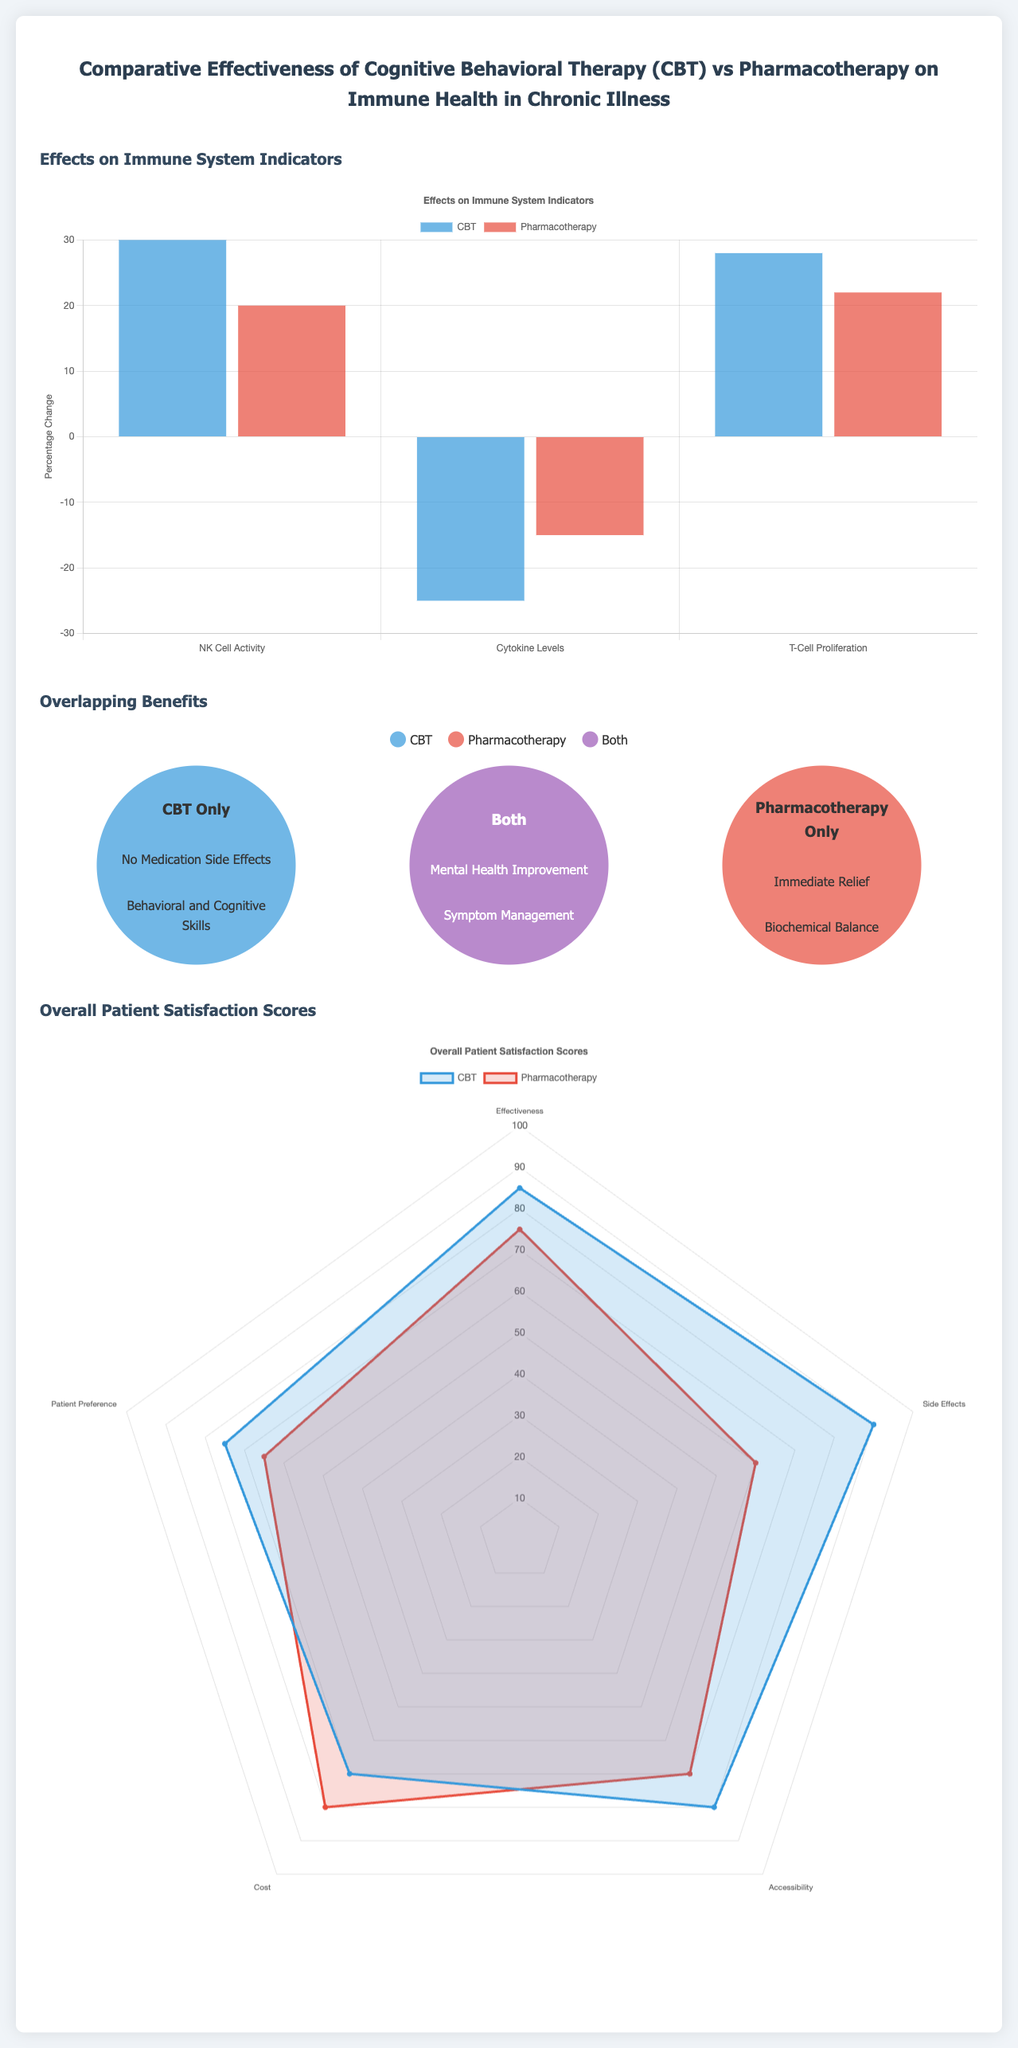What are the three immune system indicators presented? The document lists 'NK Cell Activity', 'Cytokine Levels', and 'T-Cell Proliferation' as the immune system indicators.
Answer: NK Cell Activity, Cytokine Levels, T-Cell Proliferation What was the percentage change in NK Cell Activity due to CBT? The infographic indicates that CBT led to a 30% change in NK Cell Activity.
Answer: 30 Which treatment option showed a higher patient satisfaction score for side effects? Comparing the satisfaction scores, CBT has a higher score (90) for side effects than pharmacotherapy (60).
Answer: CBT What is one unique benefit of pharmacotherapy mentioned in the Venn diagram? The document states that 'Immediate Relief' is a unique benefit of pharmacotherapy.
Answer: Immediate Relief What overall patient satisfaction score did pharmacotherapy receive for cost? The satisfaction score for pharmacotherapy in the category of cost is 80.
Answer: 80 Which treatment had a positive change in all three immune indicators? According to the data, Cognitive Behavioral Therapy (CBT) had positive changes in all three immune indicators.
Answer: CBT What common benefit do both CBT and pharmacotherapy share? Both treatment options share the benefit of 'Mental Health Improvement'.
Answer: Mental Health Improvement What color represents pharmacotherapy in the chart? In the infographic, pharmacotherapy is represented by the color red.
Answer: Red What type of chart is used to display overall patient satisfaction scores? The document uses a radar chart to display overall patient satisfaction scores.
Answer: Radar chart 